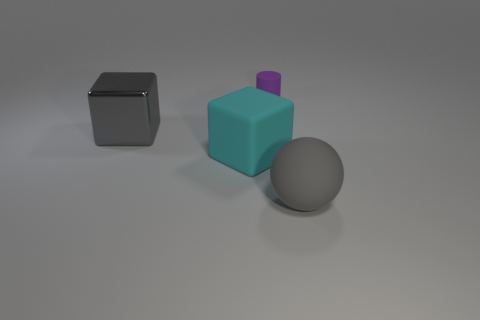Add 1 large green shiny cubes. How many objects exist? 5 Subtract all cylinders. How many objects are left? 3 Subtract 0 yellow balls. How many objects are left? 4 Subtract all large cubes. Subtract all big matte things. How many objects are left? 0 Add 2 gray metal objects. How many gray metal objects are left? 3 Add 1 small purple matte cubes. How many small purple matte cubes exist? 1 